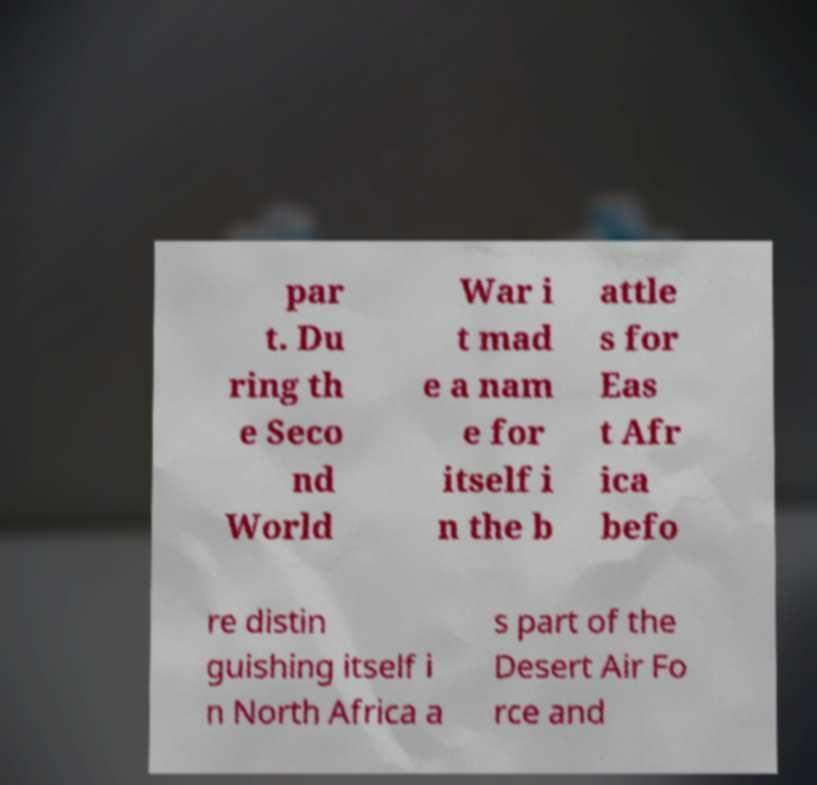I need the written content from this picture converted into text. Can you do that? par t. Du ring th e Seco nd World War i t mad e a nam e for itself i n the b attle s for Eas t Afr ica befo re distin guishing itself i n North Africa a s part of the Desert Air Fo rce and 